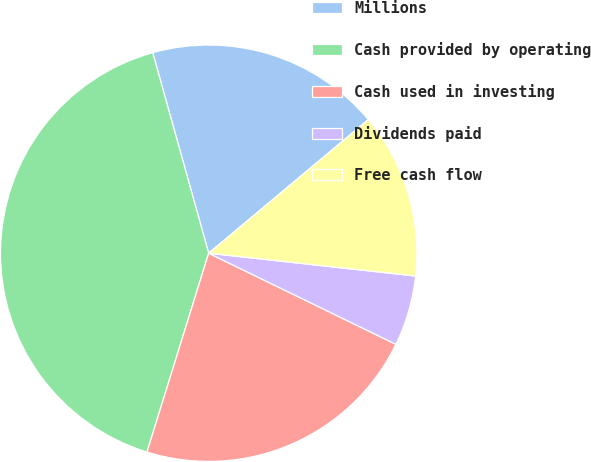Convert chart to OTSL. <chart><loc_0><loc_0><loc_500><loc_500><pie_chart><fcel>Millions<fcel>Cash provided by operating<fcel>Cash used in investing<fcel>Dividends paid<fcel>Free cash flow<nl><fcel>18.24%<fcel>40.88%<fcel>22.58%<fcel>5.46%<fcel>12.84%<nl></chart> 